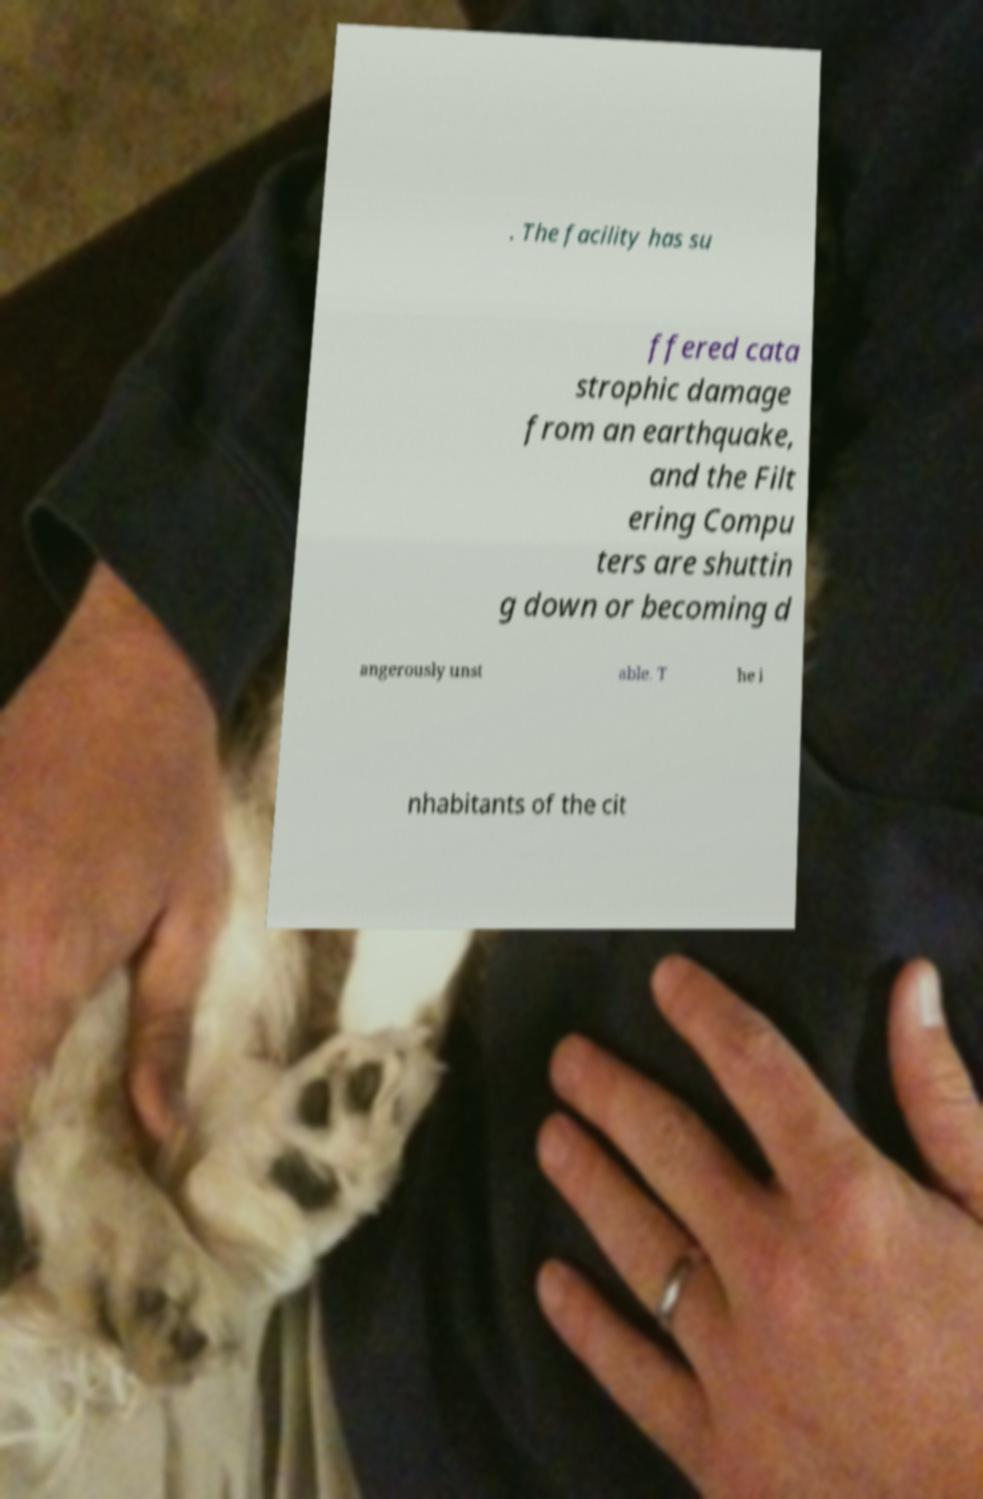Can you accurately transcribe the text from the provided image for me? . The facility has su ffered cata strophic damage from an earthquake, and the Filt ering Compu ters are shuttin g down or becoming d angerously unst able. T he i nhabitants of the cit 